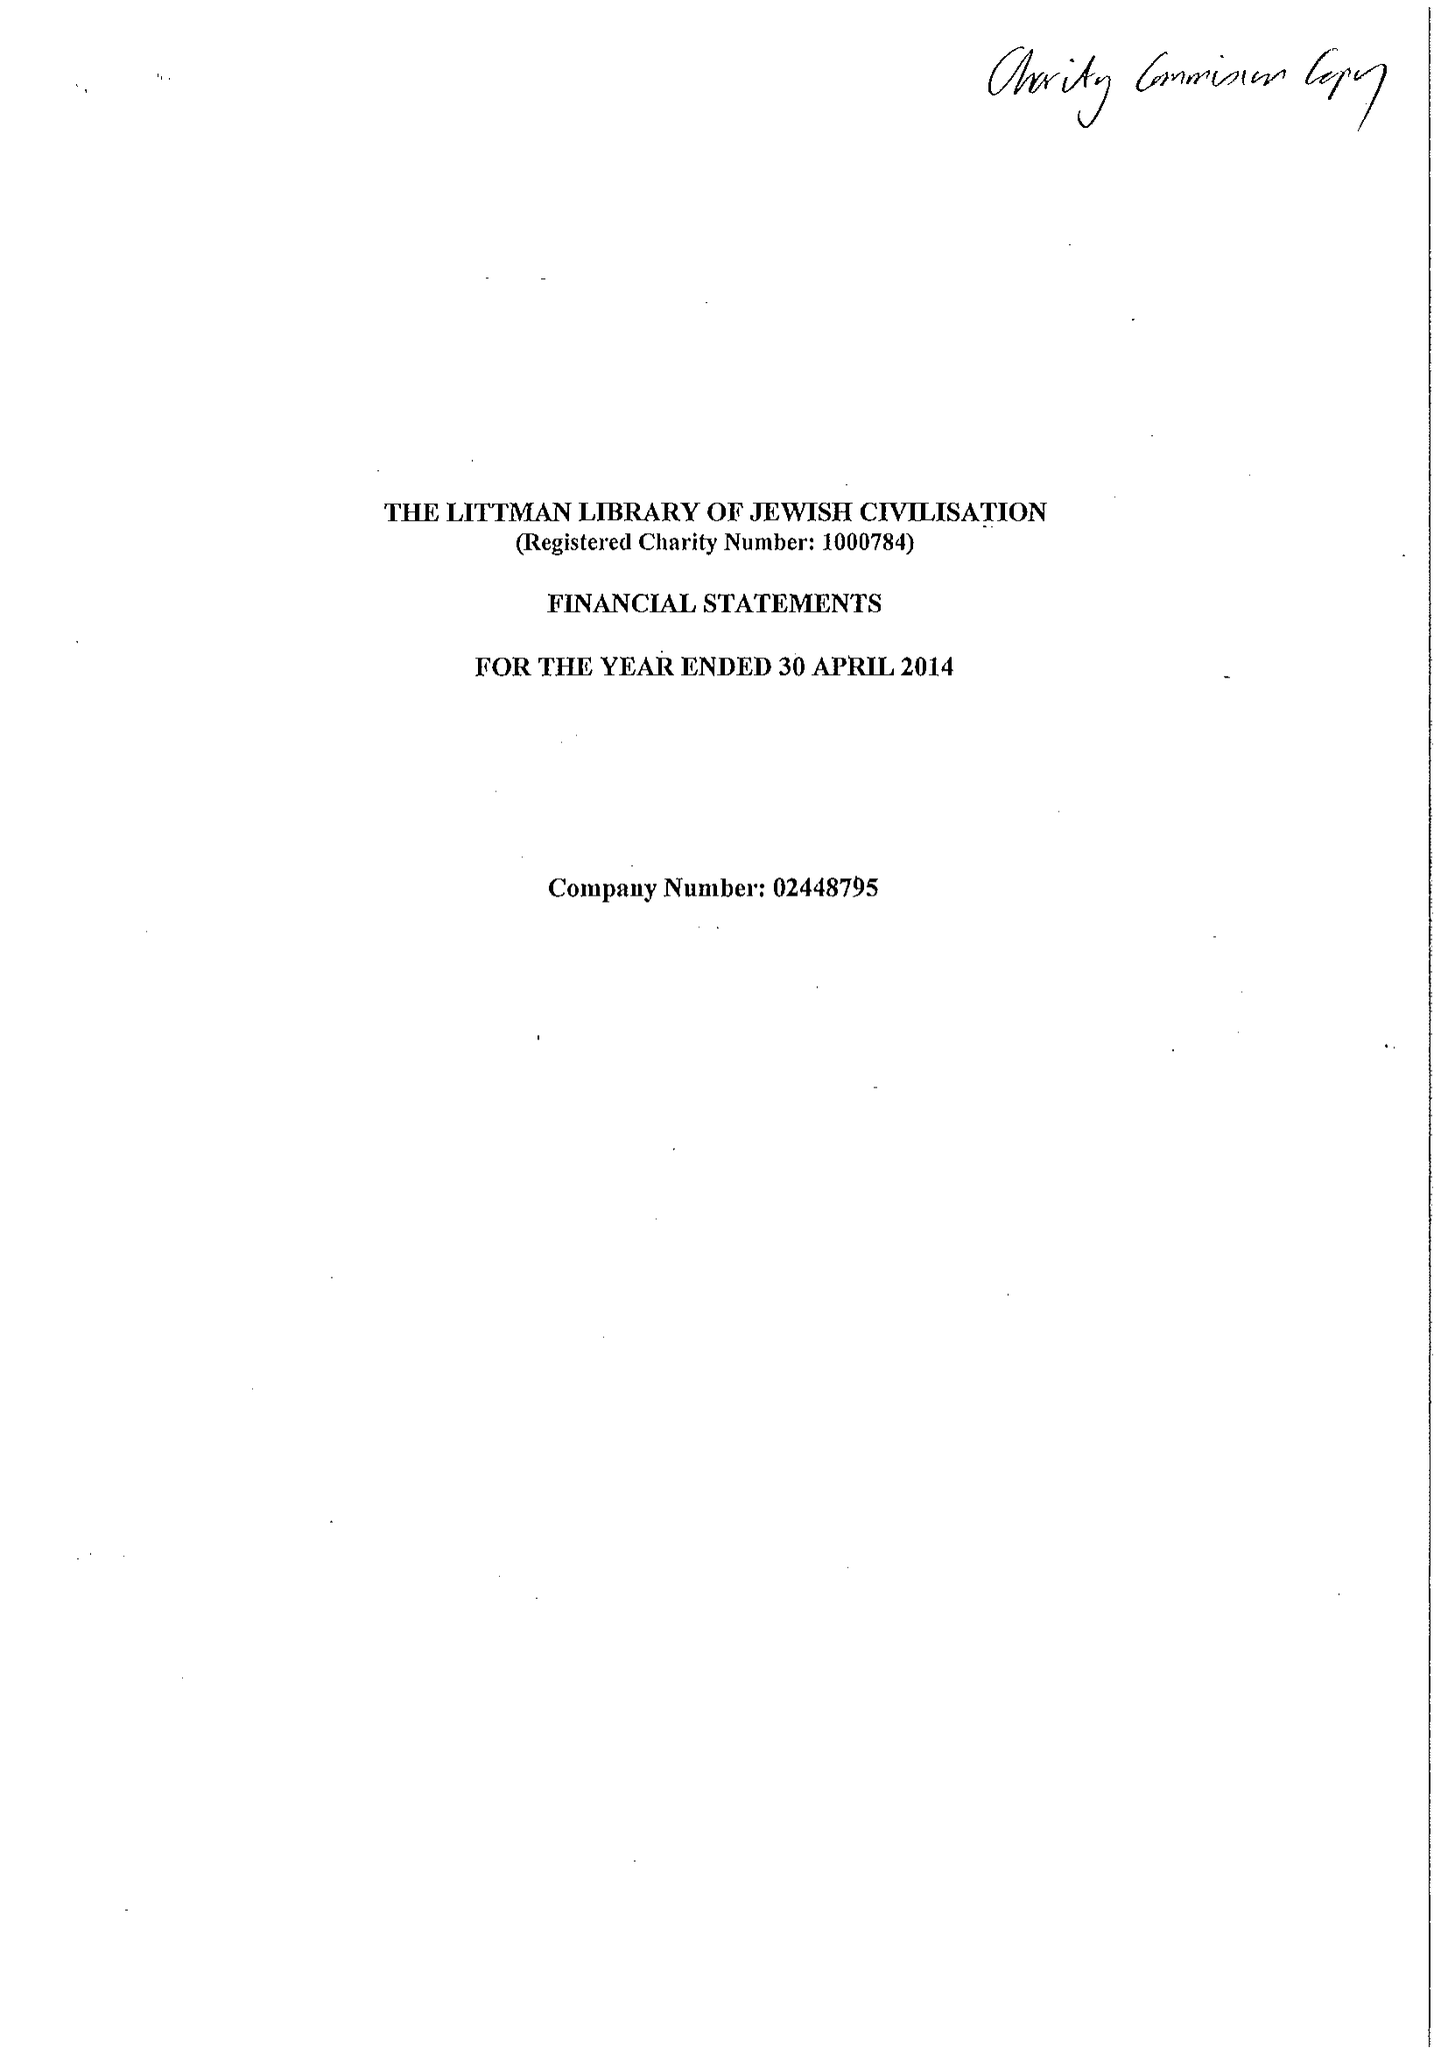What is the value for the address__postcode?
Answer the question using a single word or phrase. TA11 7BQ 